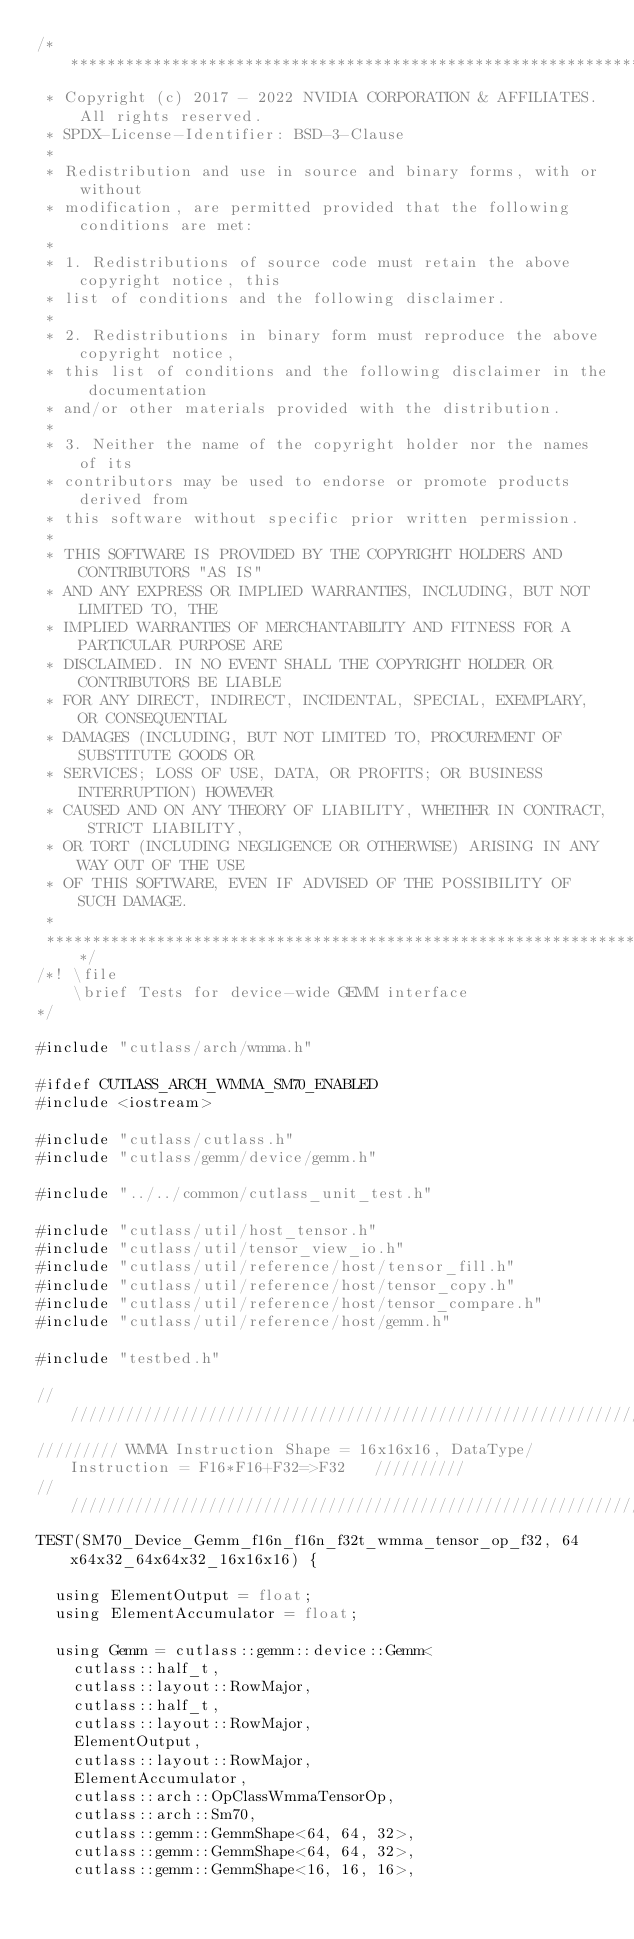<code> <loc_0><loc_0><loc_500><loc_500><_Cuda_>/***************************************************************************************************
 * Copyright (c) 2017 - 2022 NVIDIA CORPORATION & AFFILIATES. All rights reserved.
 * SPDX-License-Identifier: BSD-3-Clause
 *
 * Redistribution and use in source and binary forms, with or without
 * modification, are permitted provided that the following conditions are met:
 *
 * 1. Redistributions of source code must retain the above copyright notice, this
 * list of conditions and the following disclaimer.
 *
 * 2. Redistributions in binary form must reproduce the above copyright notice,
 * this list of conditions and the following disclaimer in the documentation
 * and/or other materials provided with the distribution.
 *
 * 3. Neither the name of the copyright holder nor the names of its
 * contributors may be used to endorse or promote products derived from
 * this software without specific prior written permission.
 *
 * THIS SOFTWARE IS PROVIDED BY THE COPYRIGHT HOLDERS AND CONTRIBUTORS "AS IS"
 * AND ANY EXPRESS OR IMPLIED WARRANTIES, INCLUDING, BUT NOT LIMITED TO, THE
 * IMPLIED WARRANTIES OF MERCHANTABILITY AND FITNESS FOR A PARTICULAR PURPOSE ARE
 * DISCLAIMED. IN NO EVENT SHALL THE COPYRIGHT HOLDER OR CONTRIBUTORS BE LIABLE
 * FOR ANY DIRECT, INDIRECT, INCIDENTAL, SPECIAL, EXEMPLARY, OR CONSEQUENTIAL
 * DAMAGES (INCLUDING, BUT NOT LIMITED TO, PROCUREMENT OF SUBSTITUTE GOODS OR
 * SERVICES; LOSS OF USE, DATA, OR PROFITS; OR BUSINESS INTERRUPTION) HOWEVER
 * CAUSED AND ON ANY THEORY OF LIABILITY, WHETHER IN CONTRACT, STRICT LIABILITY,
 * OR TORT (INCLUDING NEGLIGENCE OR OTHERWISE) ARISING IN ANY WAY OUT OF THE USE
 * OF THIS SOFTWARE, EVEN IF ADVISED OF THE POSSIBILITY OF SUCH DAMAGE.
 *
 **************************************************************************************************/
/*! \file
    \brief Tests for device-wide GEMM interface
*/

#include "cutlass/arch/wmma.h"

#ifdef CUTLASS_ARCH_WMMA_SM70_ENABLED
#include <iostream>

#include "cutlass/cutlass.h"
#include "cutlass/gemm/device/gemm.h"

#include "../../common/cutlass_unit_test.h"

#include "cutlass/util/host_tensor.h"
#include "cutlass/util/tensor_view_io.h"
#include "cutlass/util/reference/host/tensor_fill.h"
#include "cutlass/util/reference/host/tensor_copy.h"
#include "cutlass/util/reference/host/tensor_compare.h"
#include "cutlass/util/reference/host/gemm.h"

#include "testbed.h"

/////////////////////////////////////////////////////////////////////////////////////////////////
///////// WMMA Instruction Shape = 16x16x16, DataType/Instruction = F16*F16+F32=>F32   //////////
/////////////////////////////////////////////////////////////////////////////////////////////////  
TEST(SM70_Device_Gemm_f16n_f16n_f32t_wmma_tensor_op_f32, 64x64x32_64x64x32_16x16x16) {

  using ElementOutput = float;
  using ElementAccumulator = float;

  using Gemm = cutlass::gemm::device::Gemm<
    cutlass::half_t,
    cutlass::layout::RowMajor,
    cutlass::half_t,
    cutlass::layout::RowMajor,
    ElementOutput,
    cutlass::layout::RowMajor,
    ElementAccumulator,
    cutlass::arch::OpClassWmmaTensorOp,
    cutlass::arch::Sm70,
    cutlass::gemm::GemmShape<64, 64, 32>,
    cutlass::gemm::GemmShape<64, 64, 32>,
    cutlass::gemm::GemmShape<16, 16, 16>,</code> 